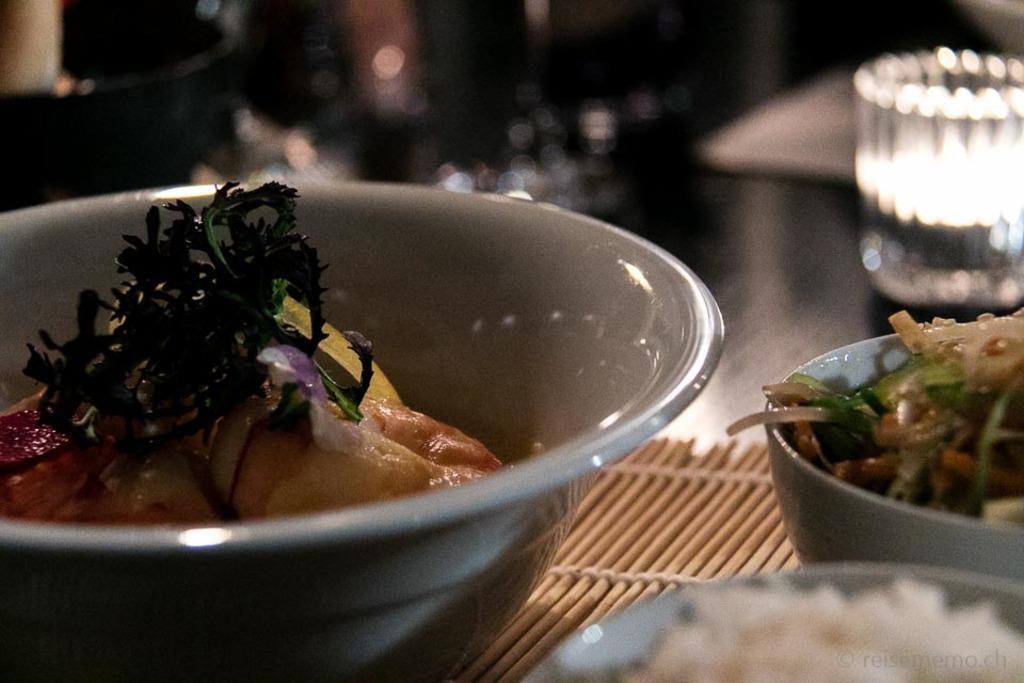Could you give a brief overview of what you see in this image? In the foreground of the image we can see three bowls containing food placed on the surface. In the background, we can see a glass. 